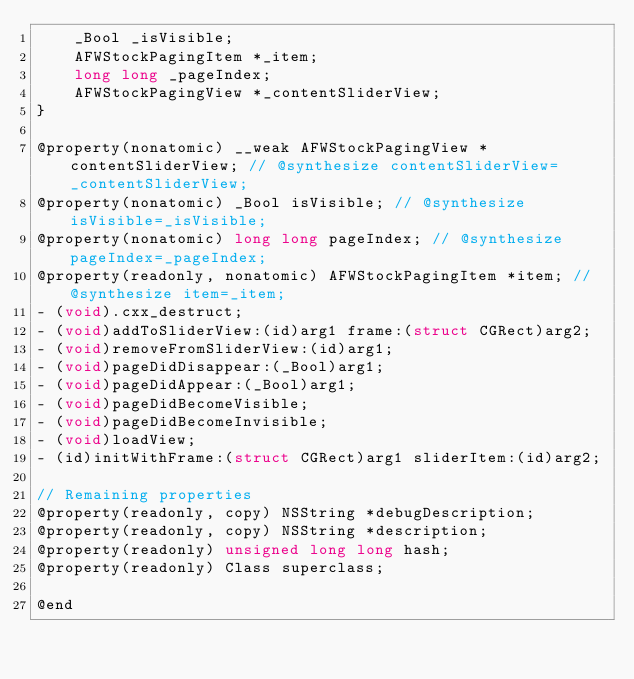Convert code to text. <code><loc_0><loc_0><loc_500><loc_500><_C_>    _Bool _isVisible;
    AFWStockPagingItem *_item;
    long long _pageIndex;
    AFWStockPagingView *_contentSliderView;
}

@property(nonatomic) __weak AFWStockPagingView *contentSliderView; // @synthesize contentSliderView=_contentSliderView;
@property(nonatomic) _Bool isVisible; // @synthesize isVisible=_isVisible;
@property(nonatomic) long long pageIndex; // @synthesize pageIndex=_pageIndex;
@property(readonly, nonatomic) AFWStockPagingItem *item; // @synthesize item=_item;
- (void).cxx_destruct;
- (void)addToSliderView:(id)arg1 frame:(struct CGRect)arg2;
- (void)removeFromSliderView:(id)arg1;
- (void)pageDidDisappear:(_Bool)arg1;
- (void)pageDidAppear:(_Bool)arg1;
- (void)pageDidBecomeVisible;
- (void)pageDidBecomeInvisible;
- (void)loadView;
- (id)initWithFrame:(struct CGRect)arg1 sliderItem:(id)arg2;

// Remaining properties
@property(readonly, copy) NSString *debugDescription;
@property(readonly, copy) NSString *description;
@property(readonly) unsigned long long hash;
@property(readonly) Class superclass;

@end

</code> 